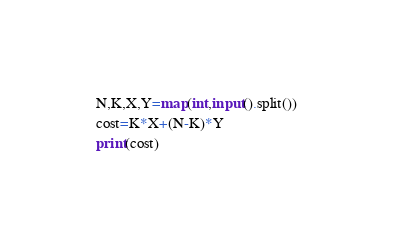Convert code to text. <code><loc_0><loc_0><loc_500><loc_500><_Python_>N,K,X,Y=map(int,input().split())
cost=K*X+(N-K)*Y
print(cost)</code> 